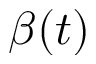<formula> <loc_0><loc_0><loc_500><loc_500>\beta ( t )</formula> 